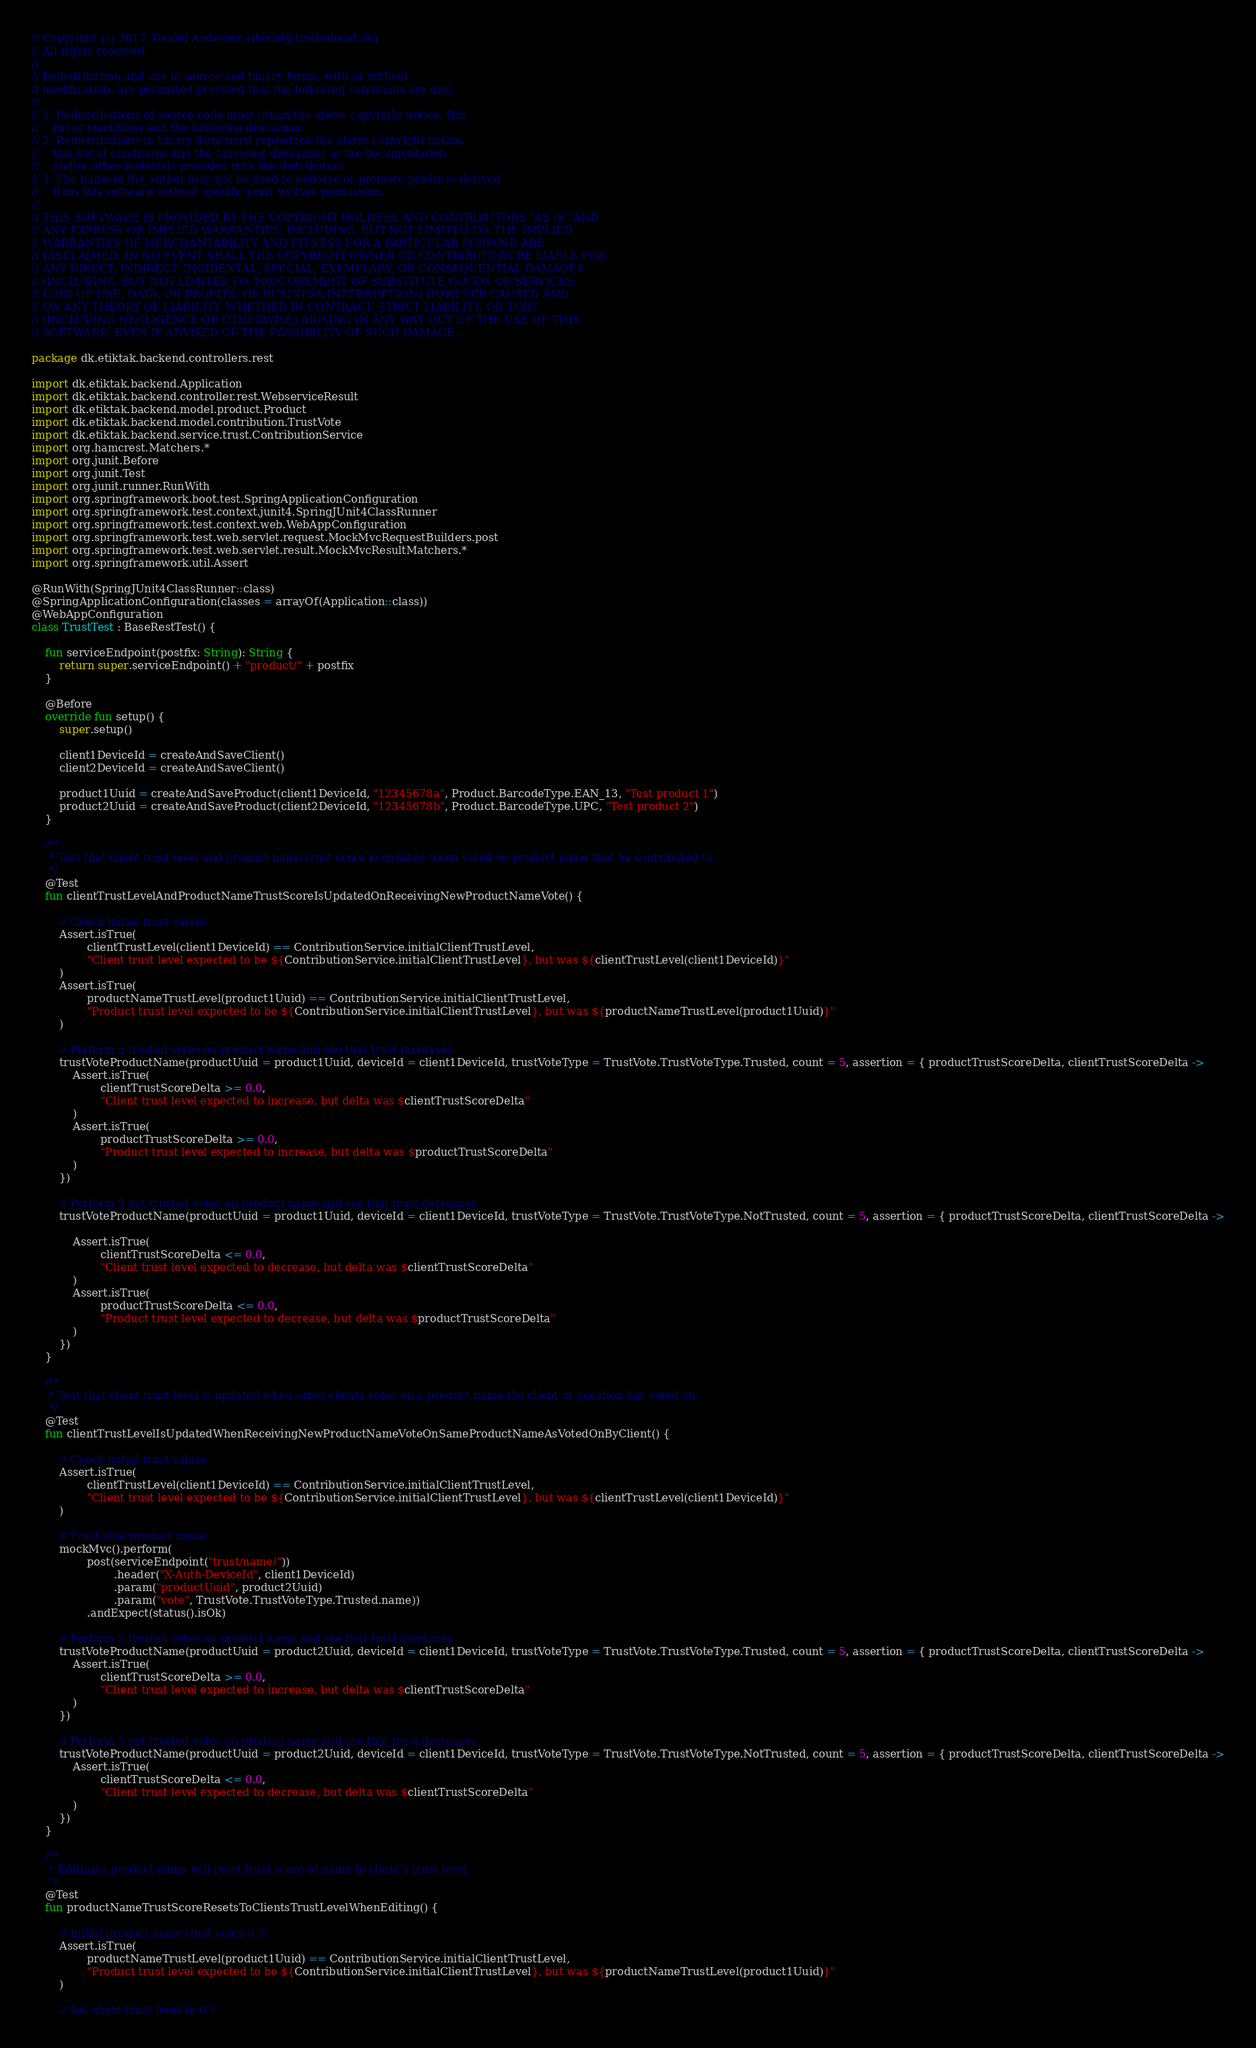Convert code to text. <code><loc_0><loc_0><loc_500><loc_500><_Kotlin_>// Copyright (c) 2017, Daniel Andersen (daniel@trollsahead.dk)
// All rights reserved.
//
// Redistribution and use in source and binary forms, with or without
// modification, are permitted provided that the following conditions are met:
//
// 1. Redistributions of source code must retain the above copyright notice, this
//    list of conditions and the following disclaimer.
// 2. Redistributions in binary form must reproduce the above copyright notice,
//    this list of conditions and the following disclaimer in the documentation
//    and/or other materials provided with the distribution.
// 3. The name of the author may not be used to endorse or promote products derived
//    from this software without specific prior written permission.
//
// THIS SOFTWARE IS PROVIDED BY THE COPYRIGHT HOLDERS AND CONTRIBUTORS "AS IS" AND
// ANY EXPRESS OR IMPLIED WARRANTIES, INCLUDING, BUT NOT LIMITED TO, THE IMPLIED
// WARRANTIES OF MERCHANTABILITY AND FITNESS FOR A PARTICULAR PURPOSE ARE
// DISCLAIMED. IN NO EVENT SHALL THE COPYRIGHT OWNER OR CONTRIBUTORS BE LIABLE FOR
// ANY DIRECT, INDIRECT, INCIDENTAL, SPECIAL, EXEMPLARY, OR CONSEQUENTIAL DAMAGES
// (INCLUDING, BUT NOT LIMITED TO, PROCUREMENT OF SUBSTITUTE GOODS OR SERVICES;
// LOSS OF USE, DATA, OR PROFITS; OR BUSINESS INTERRUPTION) HOWEVER CAUSED AND
// ON ANY THEORY OF LIABILITY, WHETHER IN CONTRACT, STRICT LIABILITY, OR TORT
// (INCLUDING NEGLIGENCE OR OTHERWISE) ARISING IN ANY WAY OUT OF THE USE OF THIS
// SOFTWARE, EVEN IF ADVISED OF THE POSSIBILITY OF SUCH DAMAGE.

package dk.etiktak.backend.controllers.rest

import dk.etiktak.backend.Application
import dk.etiktak.backend.controller.rest.WebserviceResult
import dk.etiktak.backend.model.product.Product
import dk.etiktak.backend.model.contribution.TrustVote
import dk.etiktak.backend.service.trust.ContributionService
import org.hamcrest.Matchers.*
import org.junit.Before
import org.junit.Test
import org.junit.runner.RunWith
import org.springframework.boot.test.SpringApplicationConfiguration
import org.springframework.test.context.junit4.SpringJUnit4ClassRunner
import org.springframework.test.context.web.WebAppConfiguration
import org.springframework.test.web.servlet.request.MockMvcRequestBuilders.post
import org.springframework.test.web.servlet.result.MockMvcResultMatchers.*
import org.springframework.util.Assert

@RunWith(SpringJUnit4ClassRunner::class)
@SpringApplicationConfiguration(classes = arrayOf(Application::class))
@WebAppConfiguration
class TrustTest : BaseRestTest() {

    fun serviceEndpoint(postfix: String): String {
        return super.serviceEndpoint() + "product/" + postfix
    }

    @Before
    override fun setup() {
        super.setup()

        client1DeviceId = createAndSaveClient()
        client2DeviceId = createAndSaveClient()

        product1Uuid = createAndSaveProduct(client1DeviceId, "12345678a", Product.BarcodeType.EAN_13, "Test product 1")
        product2Uuid = createAndSaveProduct(client2DeviceId, "12345678b", Product.BarcodeType.UPC, "Test product 2")
    }

    /**
     * Test that client trust level and product name trust score is updated when voted on product name that he contributed to.
     */
    @Test
    fun clientTrustLevelAndProductNameTrustScoreIsUpdatedOnReceivingNewProductNameVote() {

        // Check initial trust values
        Assert.isTrue(
                clientTrustLevel(client1DeviceId) == ContributionService.initialClientTrustLevel,
                "Client trust level expected to be ${ContributionService.initialClientTrustLevel}, but was ${clientTrustLevel(client1DeviceId)}"
        )
        Assert.isTrue(
                productNameTrustLevel(product1Uuid) == ContributionService.initialClientTrustLevel,
                "Product trust level expected to be ${ContributionService.initialClientTrustLevel}, but was ${productNameTrustLevel(product1Uuid)}"
        )

        // Perform 5 trusted votes on product name and see that trust increases
        trustVoteProductName(productUuid = product1Uuid, deviceId = client1DeviceId, trustVoteType = TrustVote.TrustVoteType.Trusted, count = 5, assertion = { productTrustScoreDelta, clientTrustScoreDelta ->
            Assert.isTrue(
                    clientTrustScoreDelta >= 0.0,
                    "Client trust level expected to increase, but delta was $clientTrustScoreDelta"
            )
            Assert.isTrue(
                    productTrustScoreDelta >= 0.0,
                    "Product trust level expected to increase, but delta was $productTrustScoreDelta"
            )
        })

        // Perform 5 not-trusted votes on product name and see that trust decreases
        trustVoteProductName(productUuid = product1Uuid, deviceId = client1DeviceId, trustVoteType = TrustVote.TrustVoteType.NotTrusted, count = 5, assertion = { productTrustScoreDelta, clientTrustScoreDelta ->

            Assert.isTrue(
                    clientTrustScoreDelta <= 0.0,
                    "Client trust level expected to decrease, but delta was $clientTrustScoreDelta"
            )
            Assert.isTrue(
                    productTrustScoreDelta <= 0.0,
                    "Product trust level expected to decrease, but delta was $productTrustScoreDelta"
            )
        })
    }

    /**
     * Test that client trust level is updated when other clients votes on a product name the client in question has voted on.
     */
    @Test
    fun clientTrustLevelIsUpdatedWhenReceivingNewProductNameVoteOnSameProductNameAsVotedOnByClient() {

        // Check initial trust values
        Assert.isTrue(
                clientTrustLevel(client1DeviceId) == ContributionService.initialClientTrustLevel,
                "Client trust level expected to be ${ContributionService.initialClientTrustLevel}, but was ${clientTrustLevel(client1DeviceId)}"
        )

        // Trust vote product name
        mockMvc().perform(
                post(serviceEndpoint("trust/name/"))
                        .header("X-Auth-DeviceId", client1DeviceId)
                        .param("productUuid", product2Uuid)
                        .param("vote", TrustVote.TrustVoteType.Trusted.name))
                .andExpect(status().isOk)

        // Perform 5 trusted votes on product name and see that trust increases
        trustVoteProductName(productUuid = product2Uuid, deviceId = client1DeviceId, trustVoteType = TrustVote.TrustVoteType.Trusted, count = 5, assertion = { productTrustScoreDelta, clientTrustScoreDelta ->
            Assert.isTrue(
                    clientTrustScoreDelta >= 0.0,
                    "Client trust level expected to increase, but delta was $clientTrustScoreDelta"
            )
        })

        // Perform 5 not-trusted votes on product name and see that trust decreases
        trustVoteProductName(productUuid = product2Uuid, deviceId = client1DeviceId, trustVoteType = TrustVote.TrustVoteType.NotTrusted, count = 5, assertion = { productTrustScoreDelta, clientTrustScoreDelta ->
            Assert.isTrue(
                    clientTrustScoreDelta <= 0.0,
                    "Client trust level expected to decrease, but delta was $clientTrustScoreDelta"
            )
        })
    }

    /**
     * Editing a product name will reset trust score of name to client's trust level
     */
    @Test
    fun productNameTrustScoreResetsToClientsTrustLevelWhenEditing() {

        // Initial product name trust score 0.5
        Assert.isTrue(
                productNameTrustLevel(product1Uuid) == ContributionService.initialClientTrustLevel,
                "Product trust level expected to be ${ContributionService.initialClientTrustLevel}, but was ${productNameTrustLevel(product1Uuid)}"
        )

        // Set client trust level to 0.7</code> 